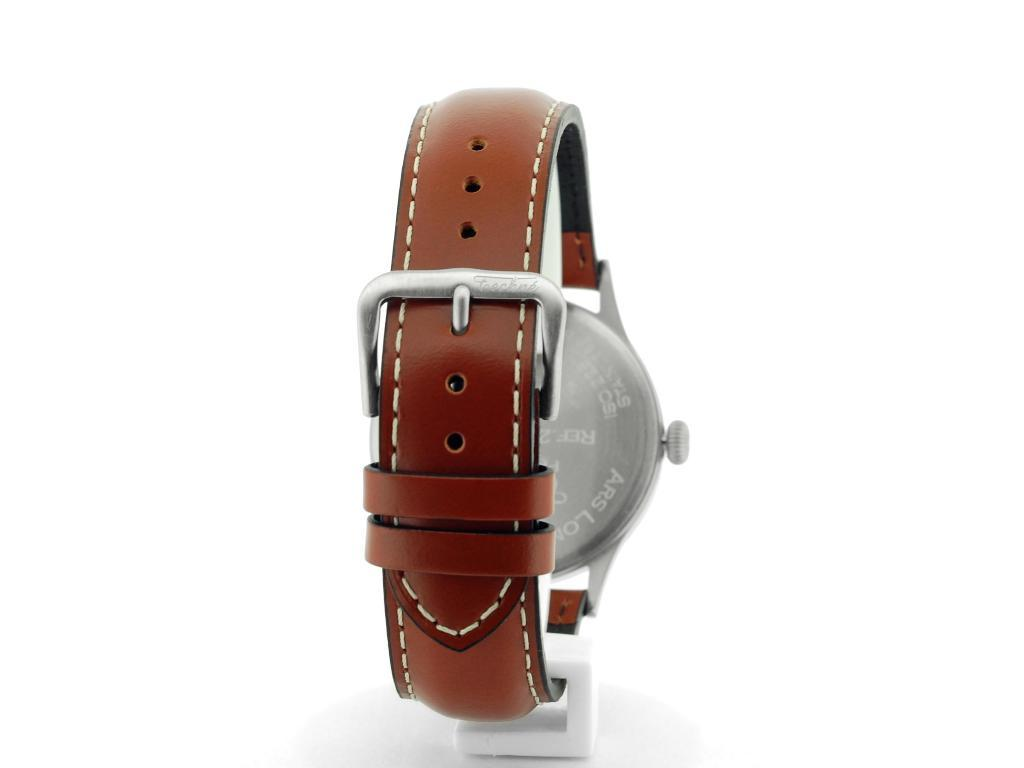What object is the main focus of the image? There is a watch in the image. Where is the watch placed? The watch is on a platform. What color is the background of the image? The background of the image is white. How many rabbits can be seen interacting with the watch in the image? There are no rabbits present in the image; it only features a watch on a platform with a white background. 